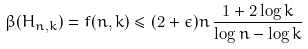Convert formula to latex. <formula><loc_0><loc_0><loc_500><loc_500>\beta ( H _ { n , k } ) = f ( n , k ) \leq ( 2 + \epsilon ) n \, \frac { 1 + 2 \log k } { \log n - \log k }</formula> 